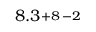<formula> <loc_0><loc_0><loc_500><loc_500>8 . 3 \substack { + 8 \, - 2 }</formula> 